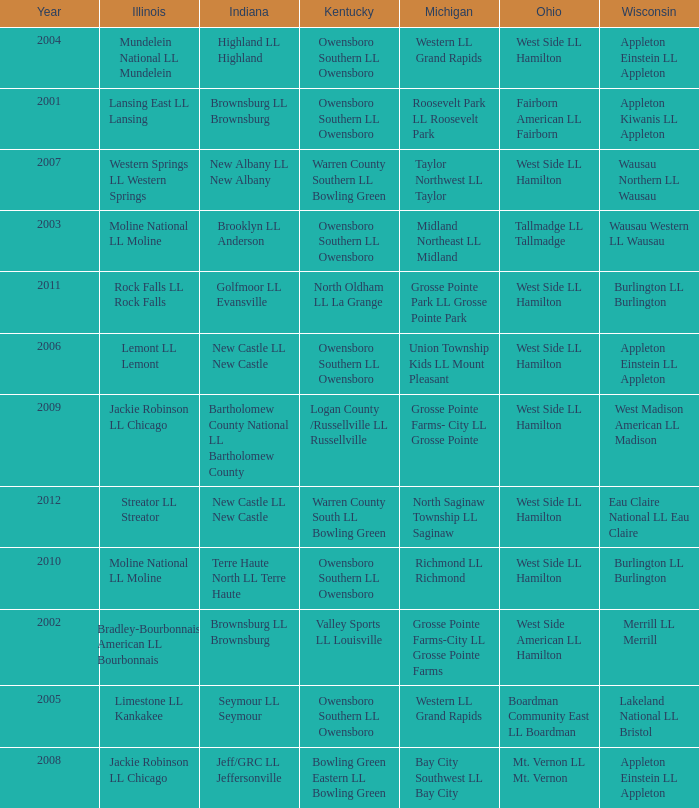What was the little league team from Kentucky when the little league team from Michigan was Grosse Pointe Farms-City LL Grosse Pointe Farms?  Valley Sports LL Louisville. 